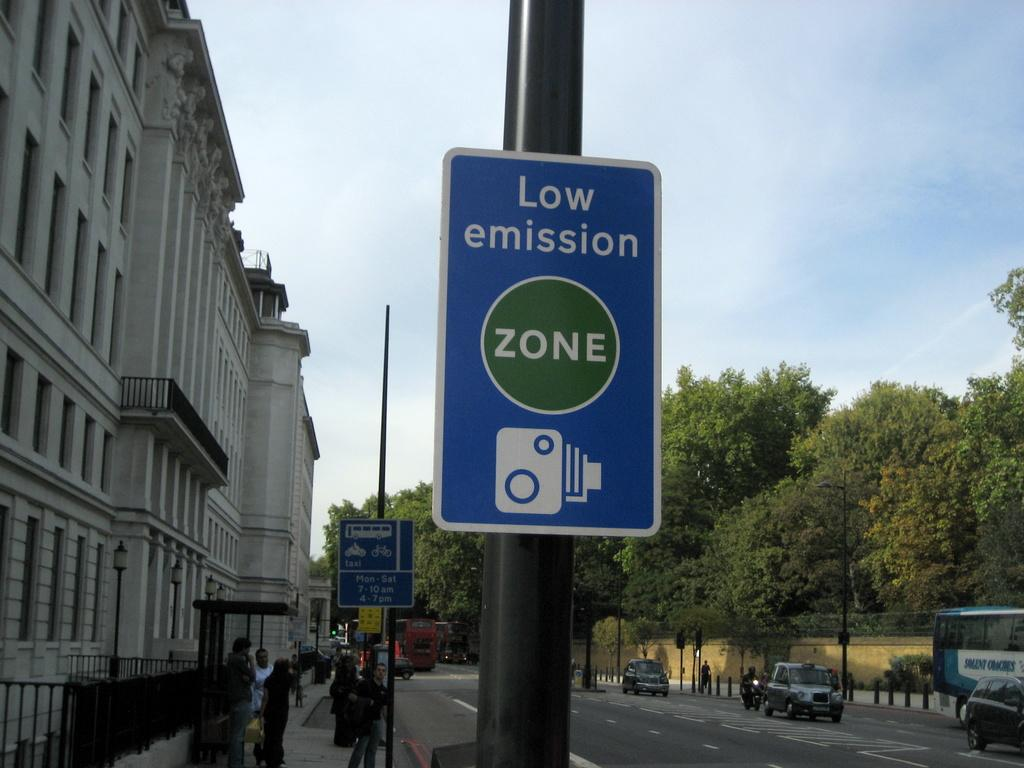Provide a one-sentence caption for the provided image. A blue sign on a street that says Low emission zone. 